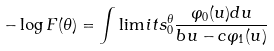Convert formula to latex. <formula><loc_0><loc_0><loc_500><loc_500>- \log F ( \theta ) = \int \lim i t s _ { 0 } ^ { \theta } \frac { \varphi _ { 0 } ( u ) d u } { b u - c \varphi _ { 1 } ( u ) }</formula> 